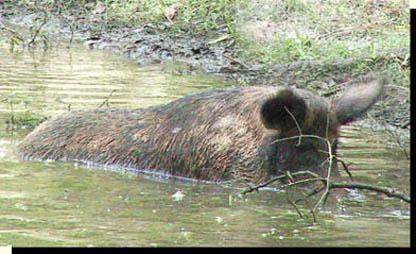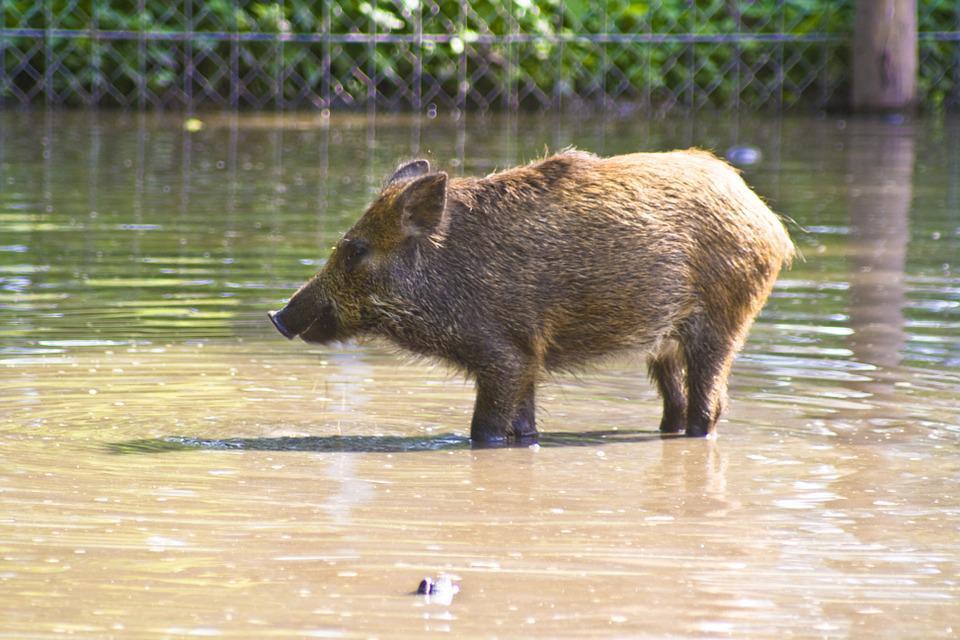The first image is the image on the left, the second image is the image on the right. For the images shown, is this caption "In at least one image there is a single boar facing right in the water next to the grassy bank." true? Answer yes or no. Yes. The first image is the image on the left, the second image is the image on the right. Assess this claim about the two images: "One image shows a single forward-facing wild pig standing in an area that is not covered in water, and the other image shows at least one pig in water.". Correct or not? Answer yes or no. No. 